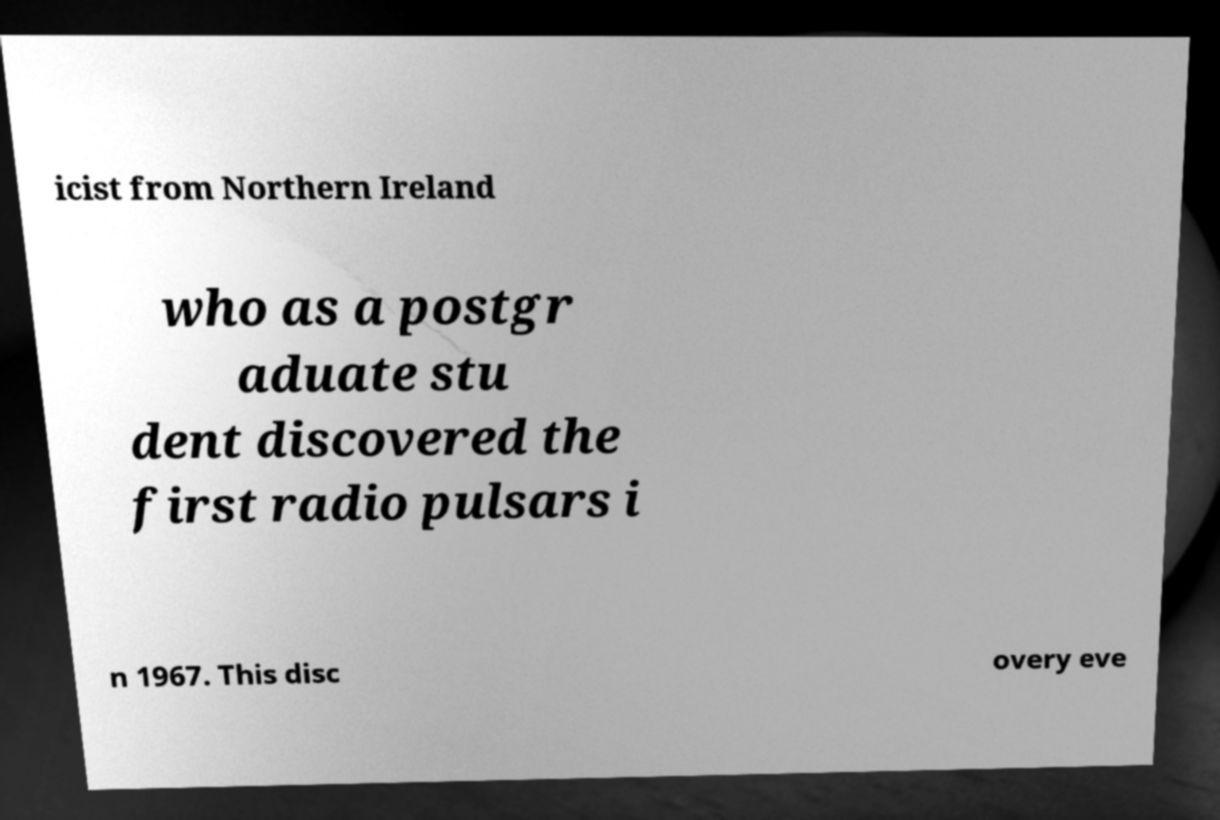Can you accurately transcribe the text from the provided image for me? icist from Northern Ireland who as a postgr aduate stu dent discovered the first radio pulsars i n 1967. This disc overy eve 